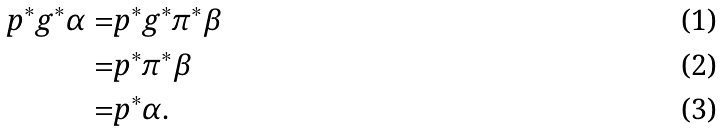<formula> <loc_0><loc_0><loc_500><loc_500>p ^ { * } g ^ { * } \alpha = & p ^ { * } g ^ { * } \pi ^ { * } \beta \\ = & p ^ { * } \pi ^ { * } \beta \\ = & p ^ { * } \alpha .</formula> 